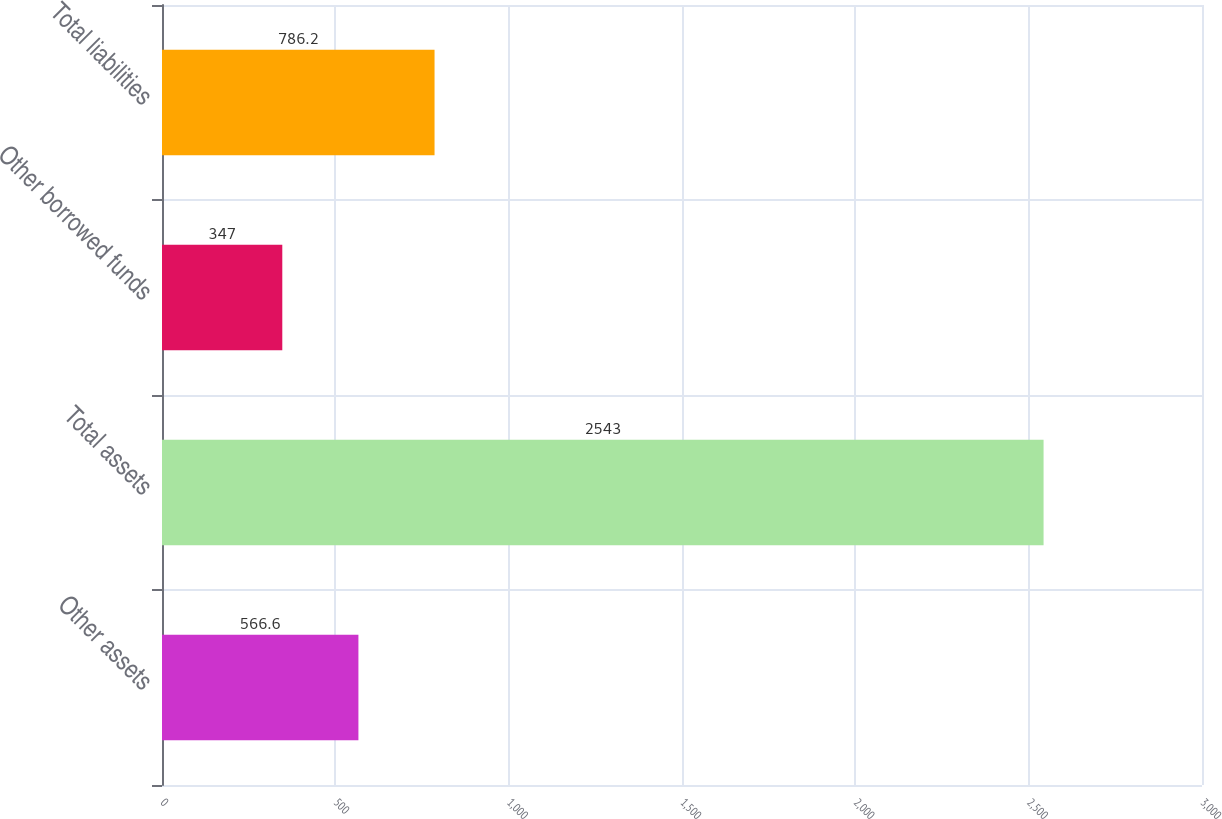<chart> <loc_0><loc_0><loc_500><loc_500><bar_chart><fcel>Other assets<fcel>Total assets<fcel>Other borrowed funds<fcel>Total liabilities<nl><fcel>566.6<fcel>2543<fcel>347<fcel>786.2<nl></chart> 